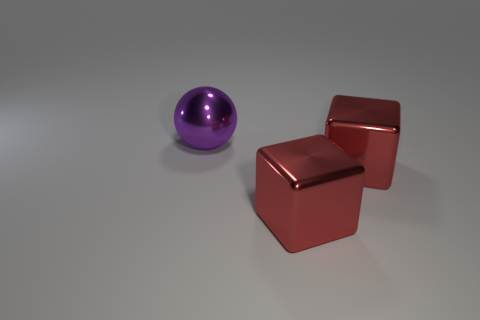How many other objects are there of the same material as the big purple object?
Offer a terse response. 2. Are there any other things that are the same shape as the big purple metal thing?
Keep it short and to the point. No. Are there fewer metallic things than big red objects?
Ensure brevity in your answer.  No. Is there any other thing that has the same size as the purple object?
Offer a terse response. Yes. What number of things are large things right of the big purple sphere or metal objects that are to the right of the large ball?
Offer a terse response. 2. What number of rubber things are red objects or large purple balls?
Make the answer very short. 0. What number of red metallic objects are behind the large purple ball?
Your answer should be very brief. 0. Is there a red object that has the same material as the big ball?
Offer a very short reply. Yes. What number of objects are yellow shiny things or big purple metallic objects?
Your answer should be very brief. 1. The purple shiny thing is what shape?
Your answer should be compact. Sphere. 